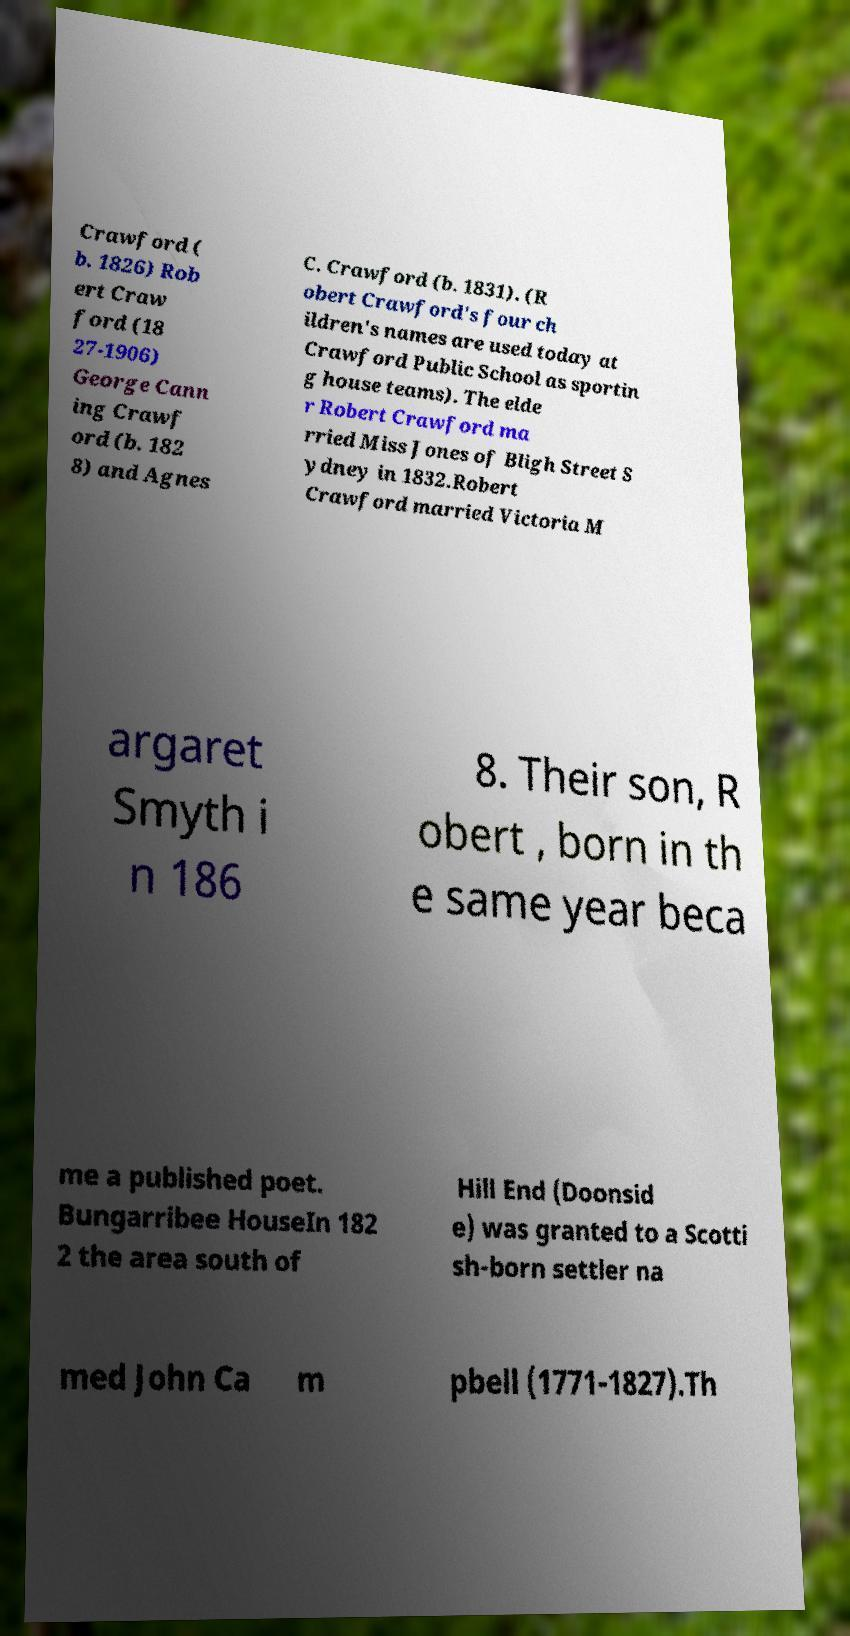I need the written content from this picture converted into text. Can you do that? Crawford ( b. 1826) Rob ert Craw ford (18 27-1906) George Cann ing Crawf ord (b. 182 8) and Agnes C. Crawford (b. 1831). (R obert Crawford's four ch ildren's names are used today at Crawford Public School as sportin g house teams). The elde r Robert Crawford ma rried Miss Jones of Bligh Street S ydney in 1832.Robert Crawford married Victoria M argaret Smyth i n 186 8. Their son, R obert , born in th e same year beca me a published poet. Bungarribee HouseIn 182 2 the area south of Hill End (Doonsid e) was granted to a Scotti sh-born settler na med John Ca m pbell (1771-1827).Th 